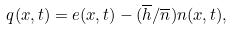Convert formula to latex. <formula><loc_0><loc_0><loc_500><loc_500>q ( x , t ) = e ( x , t ) - ( \overline { h } / \overline { n } ) n ( x , t ) ,</formula> 